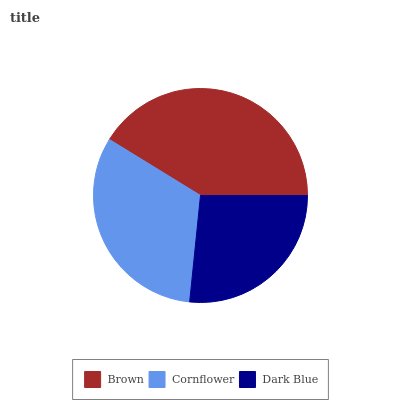Is Dark Blue the minimum?
Answer yes or no. Yes. Is Brown the maximum?
Answer yes or no. Yes. Is Cornflower the minimum?
Answer yes or no. No. Is Cornflower the maximum?
Answer yes or no. No. Is Brown greater than Cornflower?
Answer yes or no. Yes. Is Cornflower less than Brown?
Answer yes or no. Yes. Is Cornflower greater than Brown?
Answer yes or no. No. Is Brown less than Cornflower?
Answer yes or no. No. Is Cornflower the high median?
Answer yes or no. Yes. Is Cornflower the low median?
Answer yes or no. Yes. Is Brown the high median?
Answer yes or no. No. Is Brown the low median?
Answer yes or no. No. 